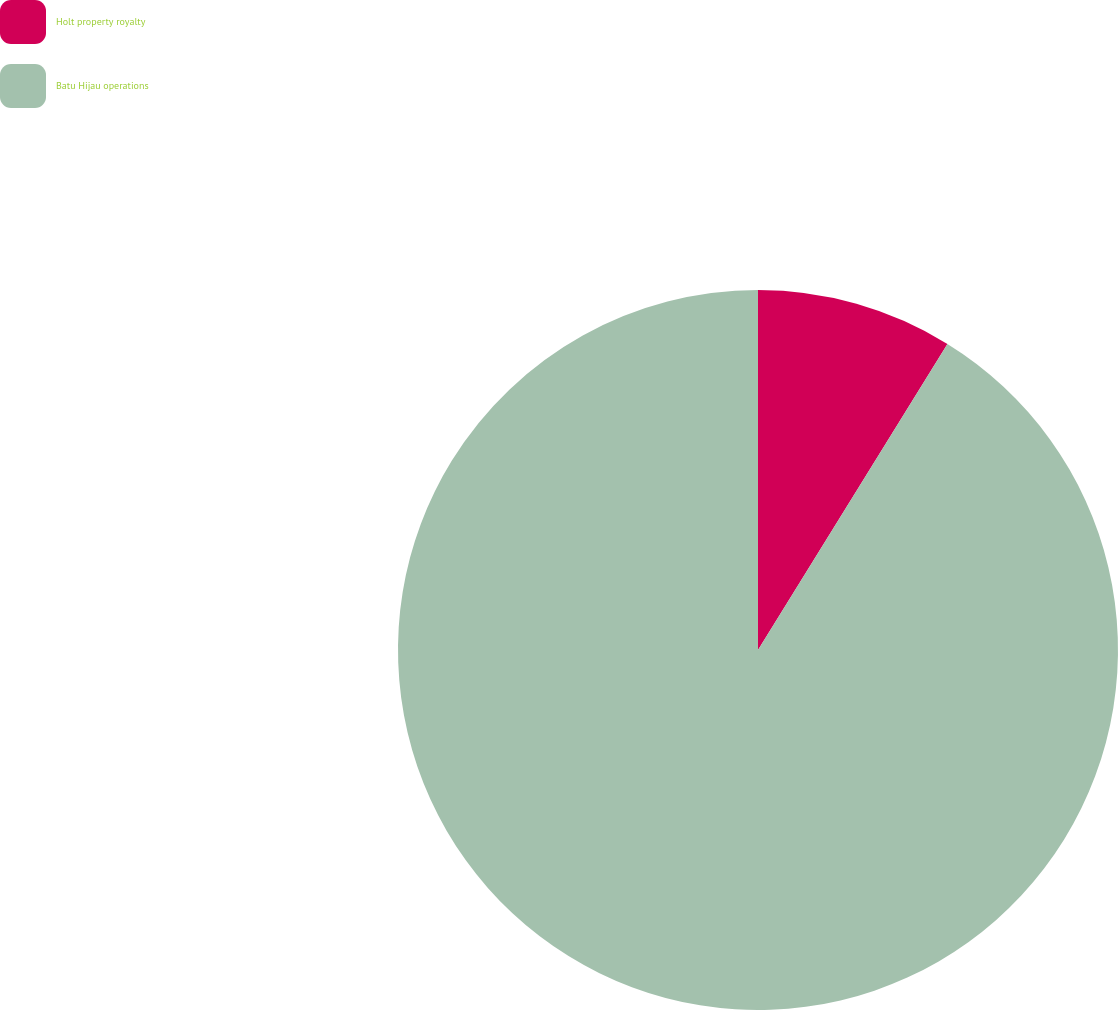Convert chart to OTSL. <chart><loc_0><loc_0><loc_500><loc_500><pie_chart><fcel>Holt property royalty<fcel>Batu Hijau operations<nl><fcel>8.82%<fcel>91.18%<nl></chart> 